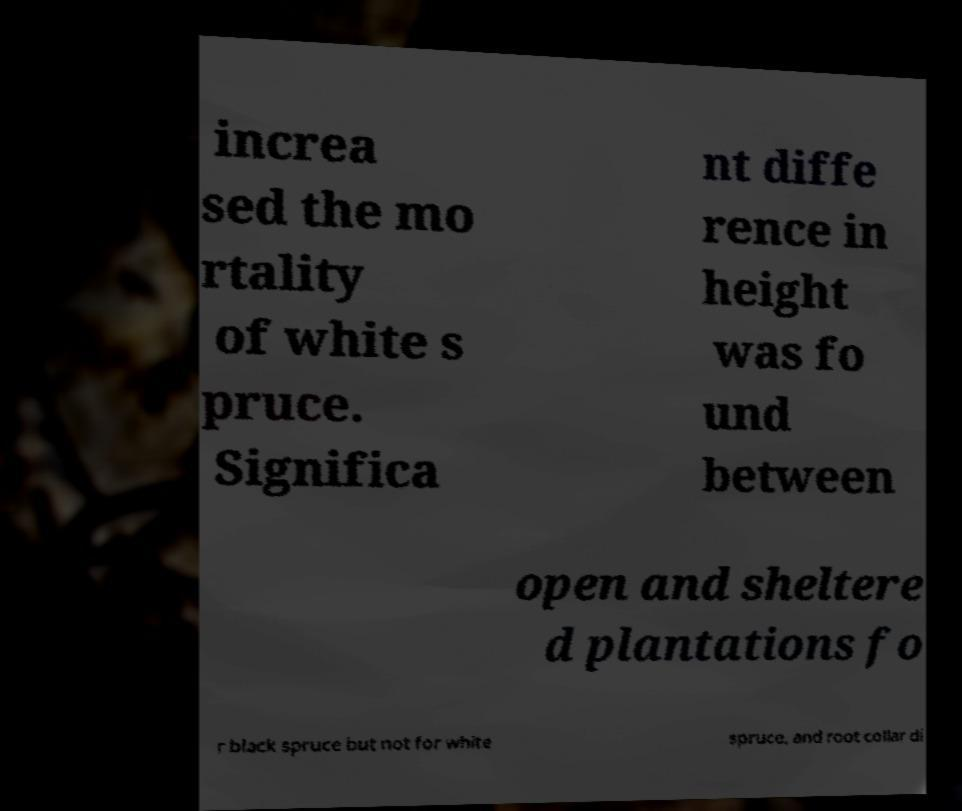Could you assist in decoding the text presented in this image and type it out clearly? increa sed the mo rtality of white s pruce. Significa nt diffe rence in height was fo und between open and sheltere d plantations fo r black spruce but not for white spruce, and root collar di 